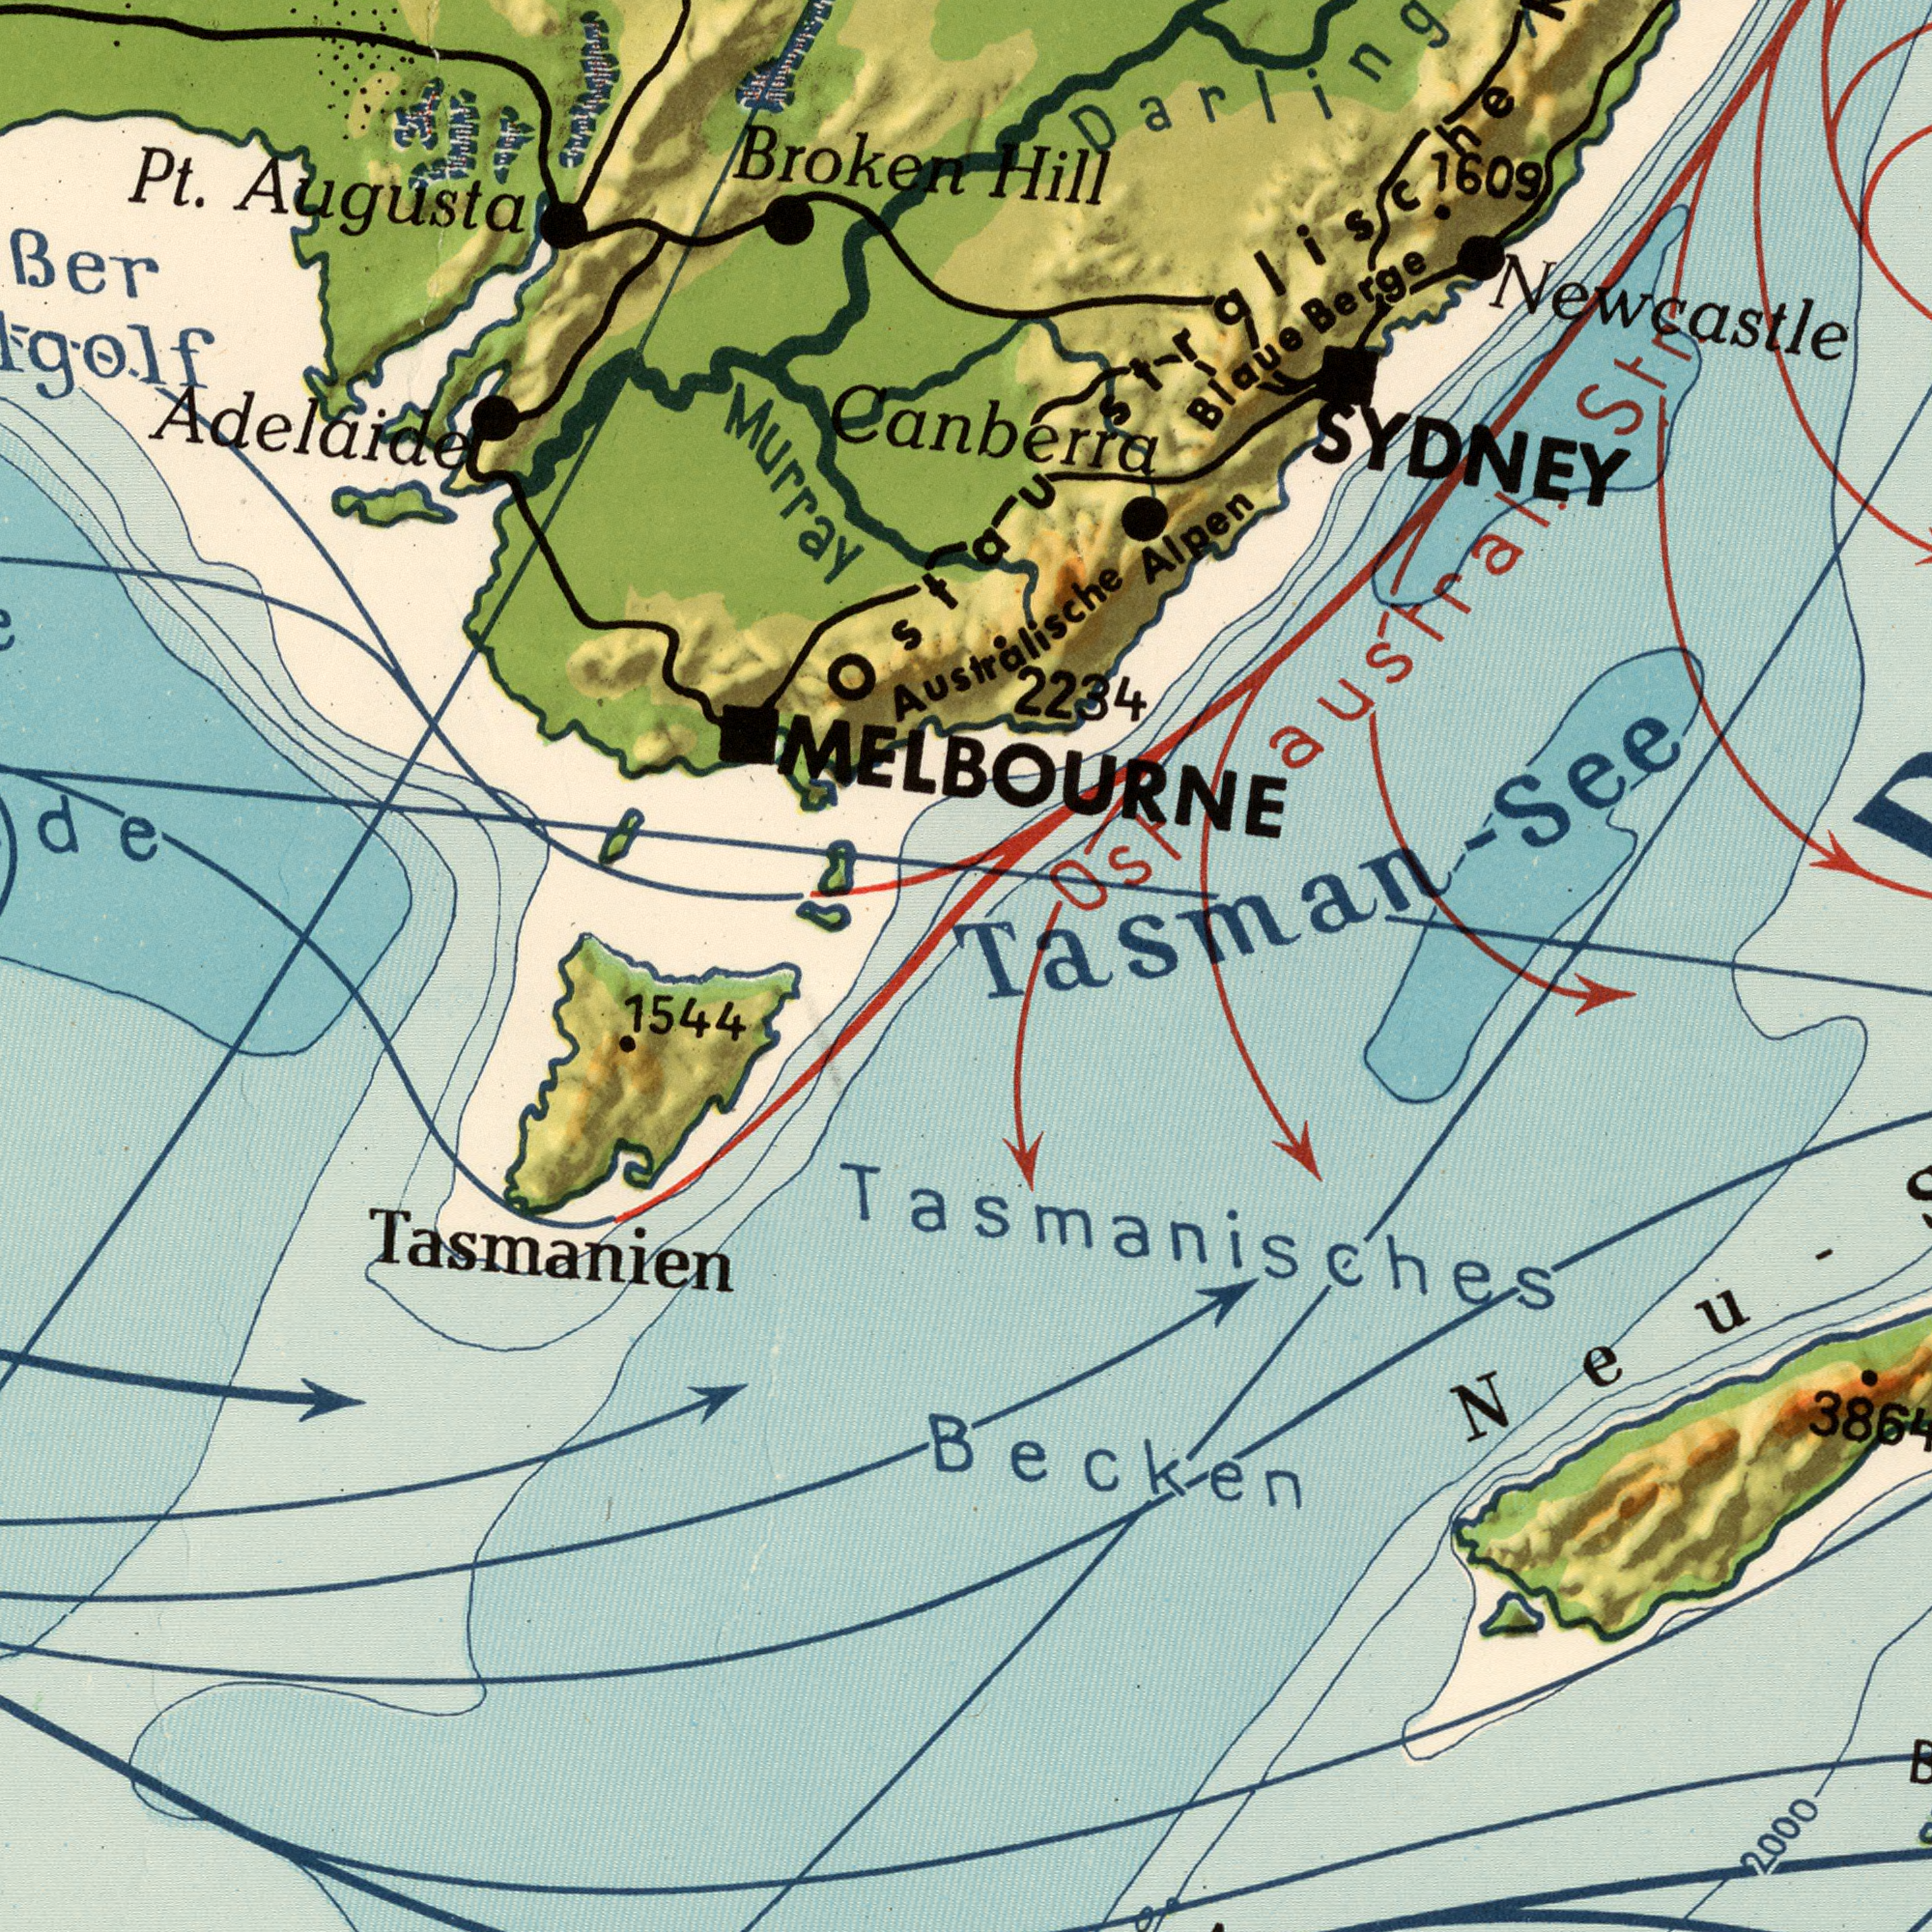What text appears in the bottom-right area of the image? 3864 2000 Becken Neu- Tasmanisches What text can you see in the top-left section? Ber Pt. Augusta Broken Adelaide Murray ###de What text appears in the bottom-left area of the image? 1544 Tasmanien What text can you see in the top-right section? Hill 2234 SYDNEY Blaue Berge Alpen 1609 Newcastle Tasman- See str. Ostaustral. Australische MELBOURNE Canberra Ostaustralische 